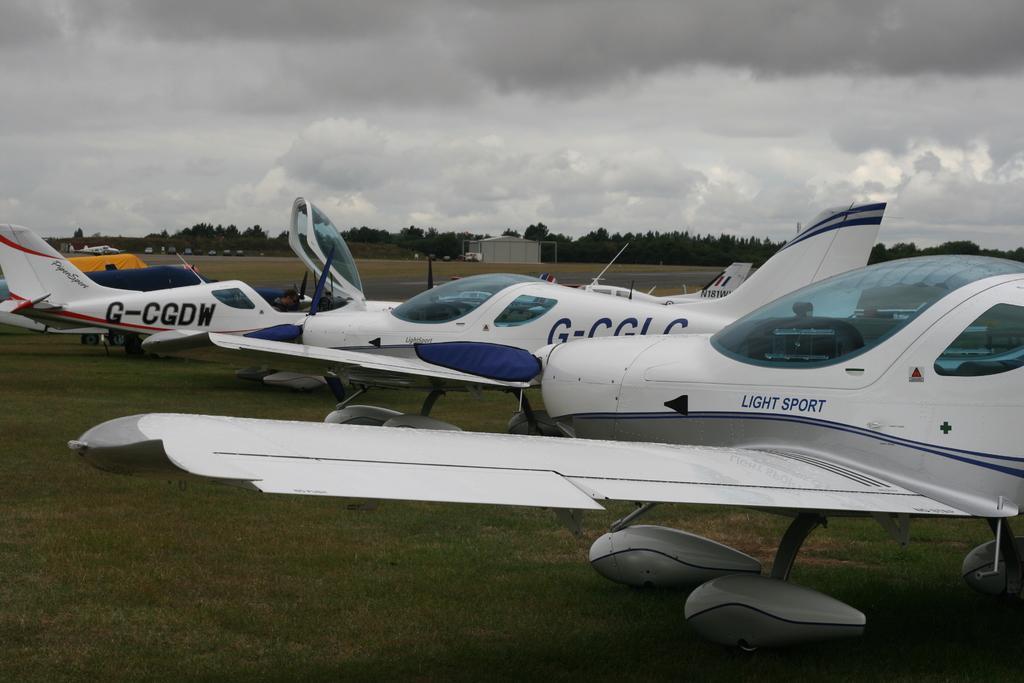Can you describe this image briefly? In the picture I can see few planes which are in white color are on a greenery ground and there are few vehicles and trees in the background and the sky is cloudy. 